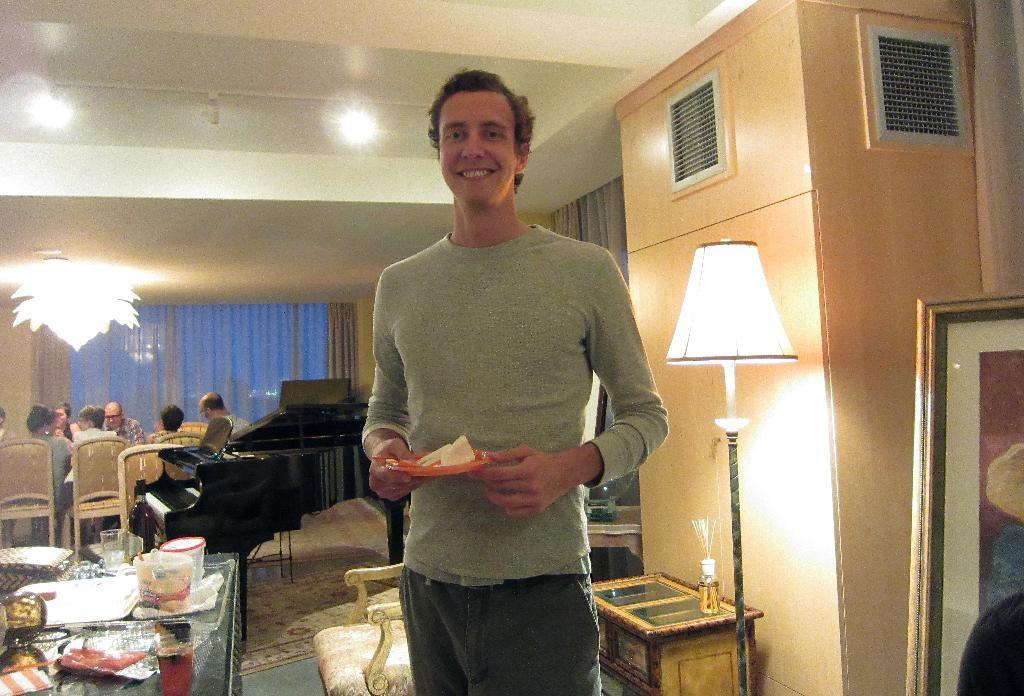Could you give a brief overview of what you see in this image? The picture is taken in a closed room. One person is standing and holding a plate behind him there is a chair and a wall and a lamp and a table and some bottle on it. Behind the chair in front of it there is a table and some glass jars and plates present on the table and at the right corner of the many people are sitting on the chairs, behind them there is bog window with curtains and there are lights. 